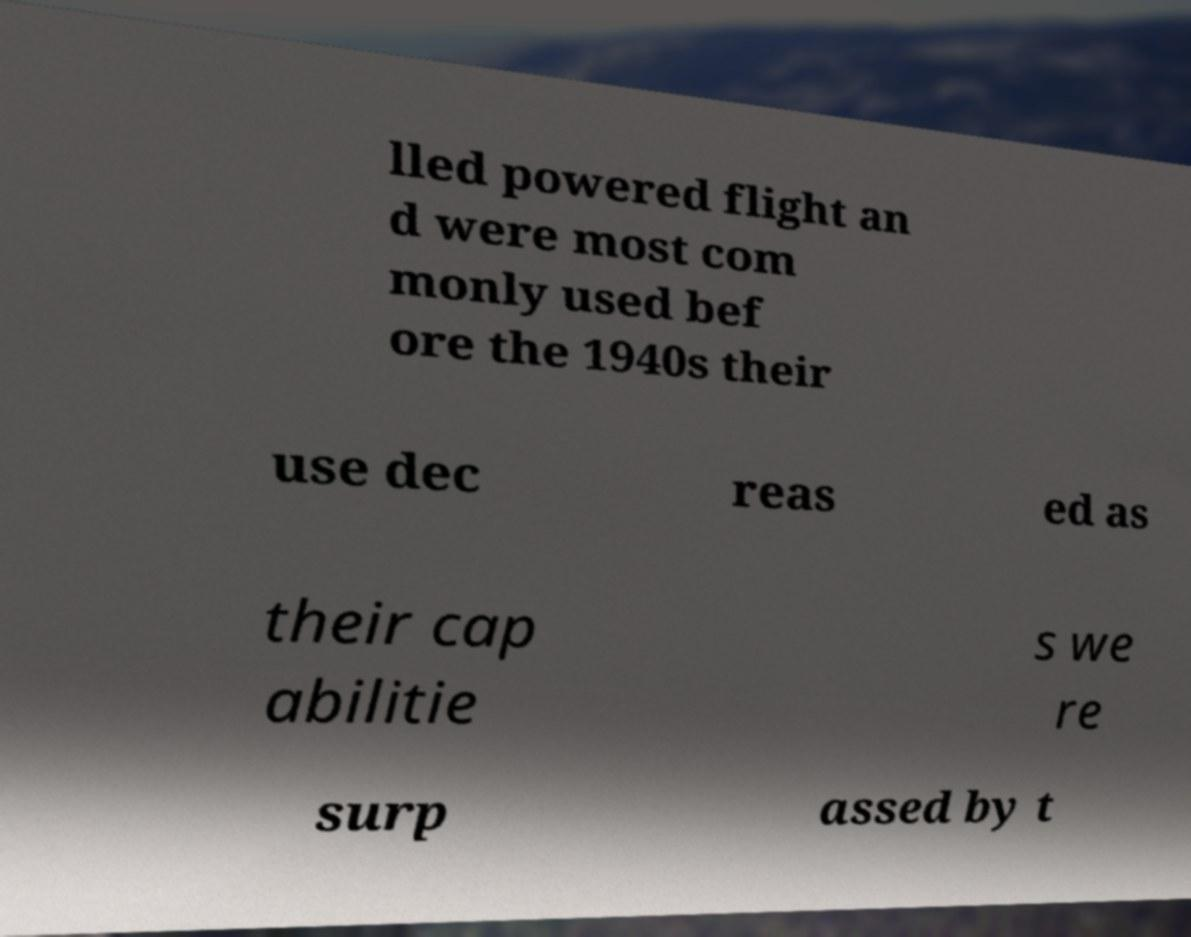What messages or text are displayed in this image? I need them in a readable, typed format. lled powered flight an d were most com monly used bef ore the 1940s their use dec reas ed as their cap abilitie s we re surp assed by t 